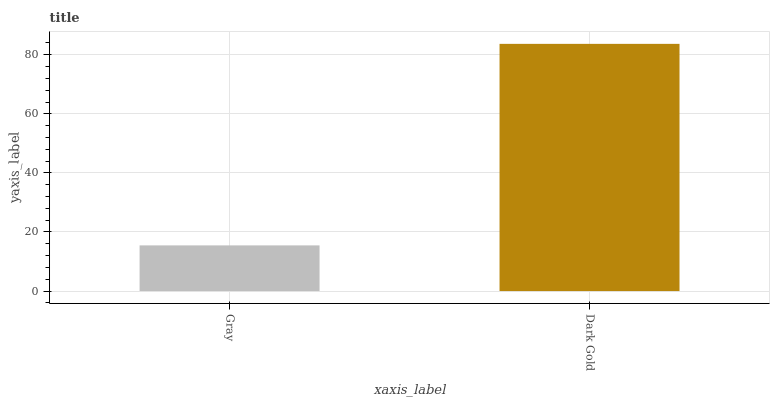Is Gray the minimum?
Answer yes or no. Yes. Is Dark Gold the maximum?
Answer yes or no. Yes. Is Dark Gold the minimum?
Answer yes or no. No. Is Dark Gold greater than Gray?
Answer yes or no. Yes. Is Gray less than Dark Gold?
Answer yes or no. Yes. Is Gray greater than Dark Gold?
Answer yes or no. No. Is Dark Gold less than Gray?
Answer yes or no. No. Is Dark Gold the high median?
Answer yes or no. Yes. Is Gray the low median?
Answer yes or no. Yes. Is Gray the high median?
Answer yes or no. No. Is Dark Gold the low median?
Answer yes or no. No. 